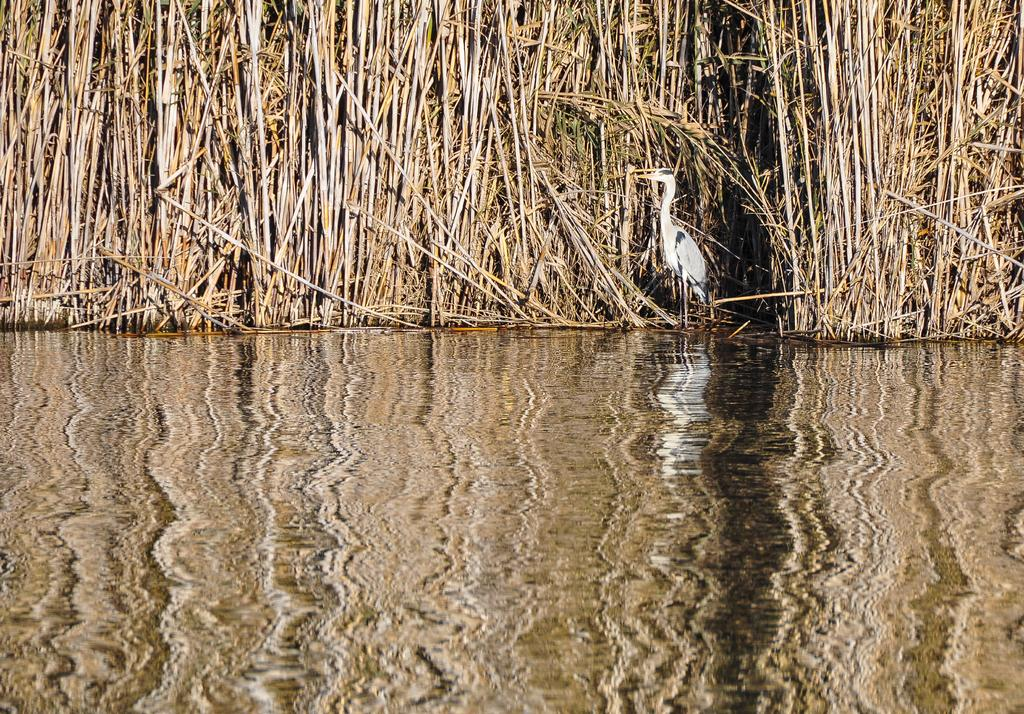What type of animal can be seen in the image? There is a bird in the image. What else is present in the image besides the bird? There are plants and water visible in the image. Can you describe the water in the image? The water is visible at the bottom of the image and has reflections on it. What type of soap is being used to rub the bird in the image? There is no soap or rubbing action involving the bird in the image. 